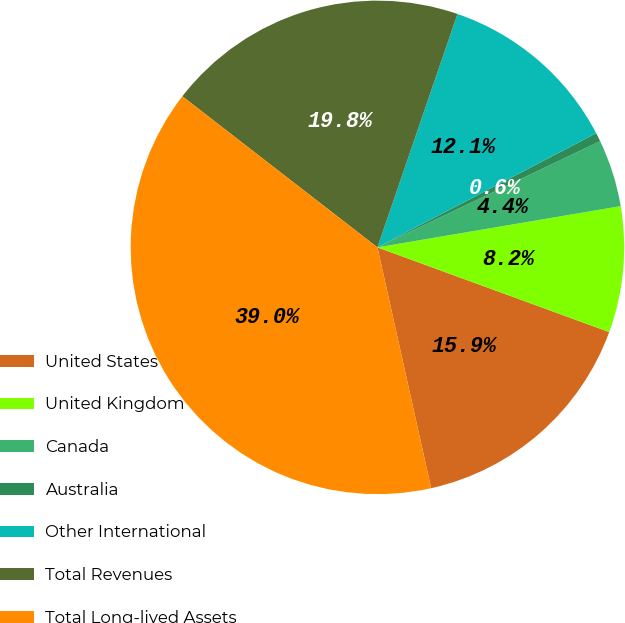Convert chart. <chart><loc_0><loc_0><loc_500><loc_500><pie_chart><fcel>United States<fcel>United Kingdom<fcel>Canada<fcel>Australia<fcel>Other International<fcel>Total Revenues<fcel>Total Long-lived Assets<nl><fcel>15.93%<fcel>8.25%<fcel>4.41%<fcel>0.57%<fcel>12.09%<fcel>19.77%<fcel>38.98%<nl></chart> 